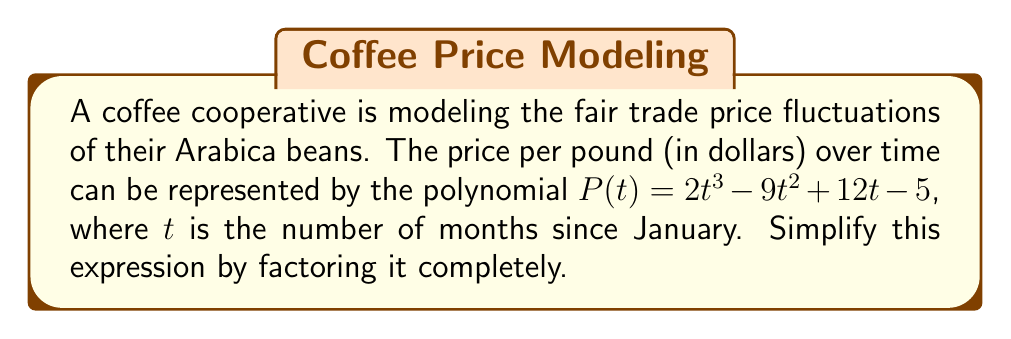Could you help me with this problem? To simplify this polynomial by factoring, we'll follow these steps:

1) First, let's check if there's a common factor for all terms:
   $P(t) = 2t^3 - 9t^2 + 12t - 5$
   There's no common factor, so we move to the next step.

2) This is a cubic polynomial. Let's try to find a factor by guessing rational roots. Possible rational roots are factors of the constant term (±1, ±5).

3) Testing these values, we find that $P(1) = 0$. So $(t-1)$ is a factor.

4) Let's use polynomial long division to divide $P(t)$ by $(t-1)$:

   $$\begin{array}{r}
   2t^2 + (-7t) + 5 \\
   t - 1 \enclose{longdiv}{2t^3 - 9t^2 + 12t - 5} \\
   \underline{2t^3 - 2t^2} \\
   -7t^2 + 12t \\
   \underline{-7t^2 + 7t} \\
   5t - 5 \\
   \underline{5t - 5} \\
   0
   \end{array}$$

5) So, $P(t) = (t-1)(2t^2 - 7t + 5)$

6) Now, let's factor the quadratic term $2t^2 - 7t + 5$:
   
   The discriminant $b^2 - 4ac = (-7)^2 - 4(2)(5) = 49 - 40 = 9$
   
   Roots: $\frac{7 \pm \sqrt{9}}{2(2)} = \frac{7 \pm 3}{4}$

   So, $2t^2 - 7t + 5 = 2(t - \frac{5}{2})(t - \frac{1}{2})$

7) Therefore, the fully factored polynomial is:
   $P(t) = (t-1)(2t - 5)(t - \frac{1}{2})$
Answer: $P(t) = (t-1)(2t - 5)(t - \frac{1}{2})$ 